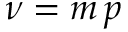Convert formula to latex. <formula><loc_0><loc_0><loc_500><loc_500>\nu = m \, p</formula> 